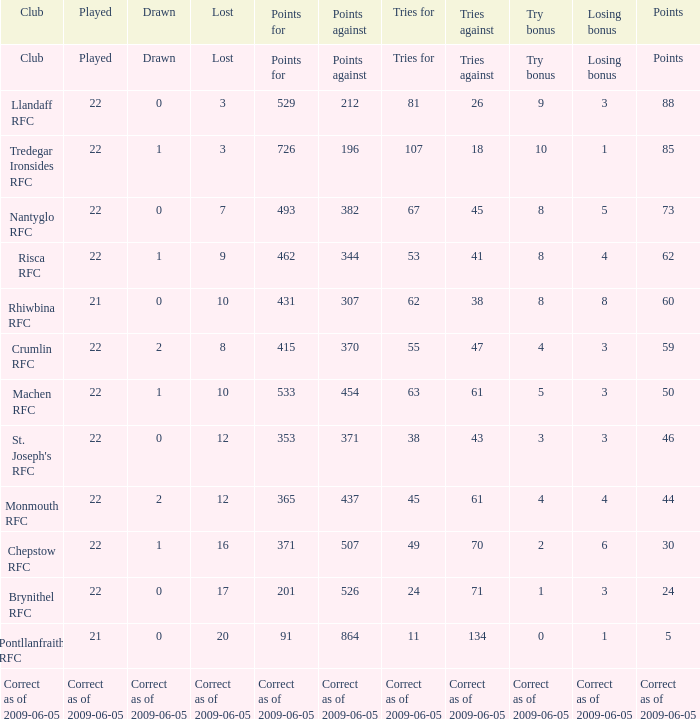What's the losing bonus of Crumlin RFC? 3.0. 